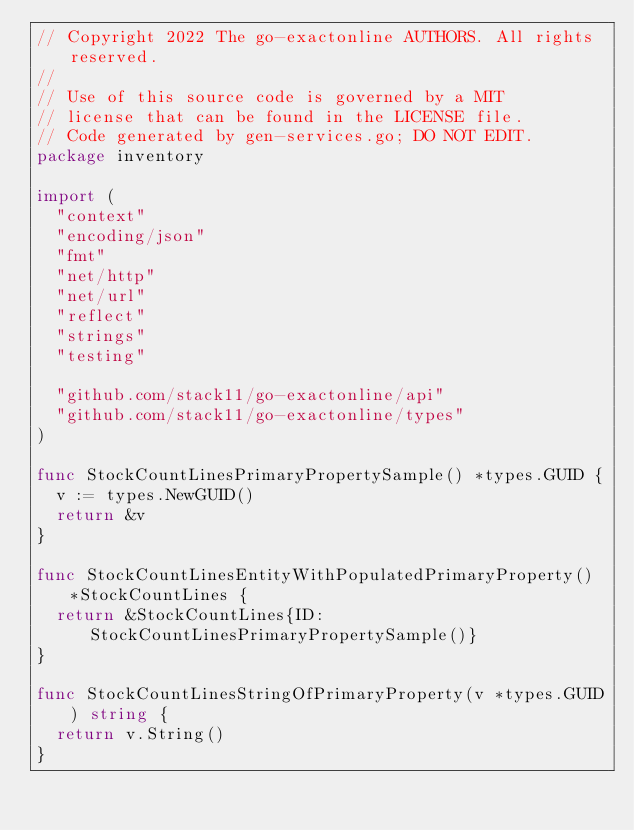Convert code to text. <code><loc_0><loc_0><loc_500><loc_500><_Go_>// Copyright 2022 The go-exactonline AUTHORS. All rights reserved.
//
// Use of this source code is governed by a MIT
// license that can be found in the LICENSE file.
// Code generated by gen-services.go; DO NOT EDIT.
package inventory

import (
	"context"
	"encoding/json"
	"fmt"
	"net/http"
	"net/url"
	"reflect"
	"strings"
	"testing"

	"github.com/stack11/go-exactonline/api"
	"github.com/stack11/go-exactonline/types"
)

func StockCountLinesPrimaryPropertySample() *types.GUID {
	v := types.NewGUID()
	return &v
}

func StockCountLinesEntityWithPopulatedPrimaryProperty() *StockCountLines {
	return &StockCountLines{ID: StockCountLinesPrimaryPropertySample()}
}

func StockCountLinesStringOfPrimaryProperty(v *types.GUID) string {
	return v.String()
}
</code> 